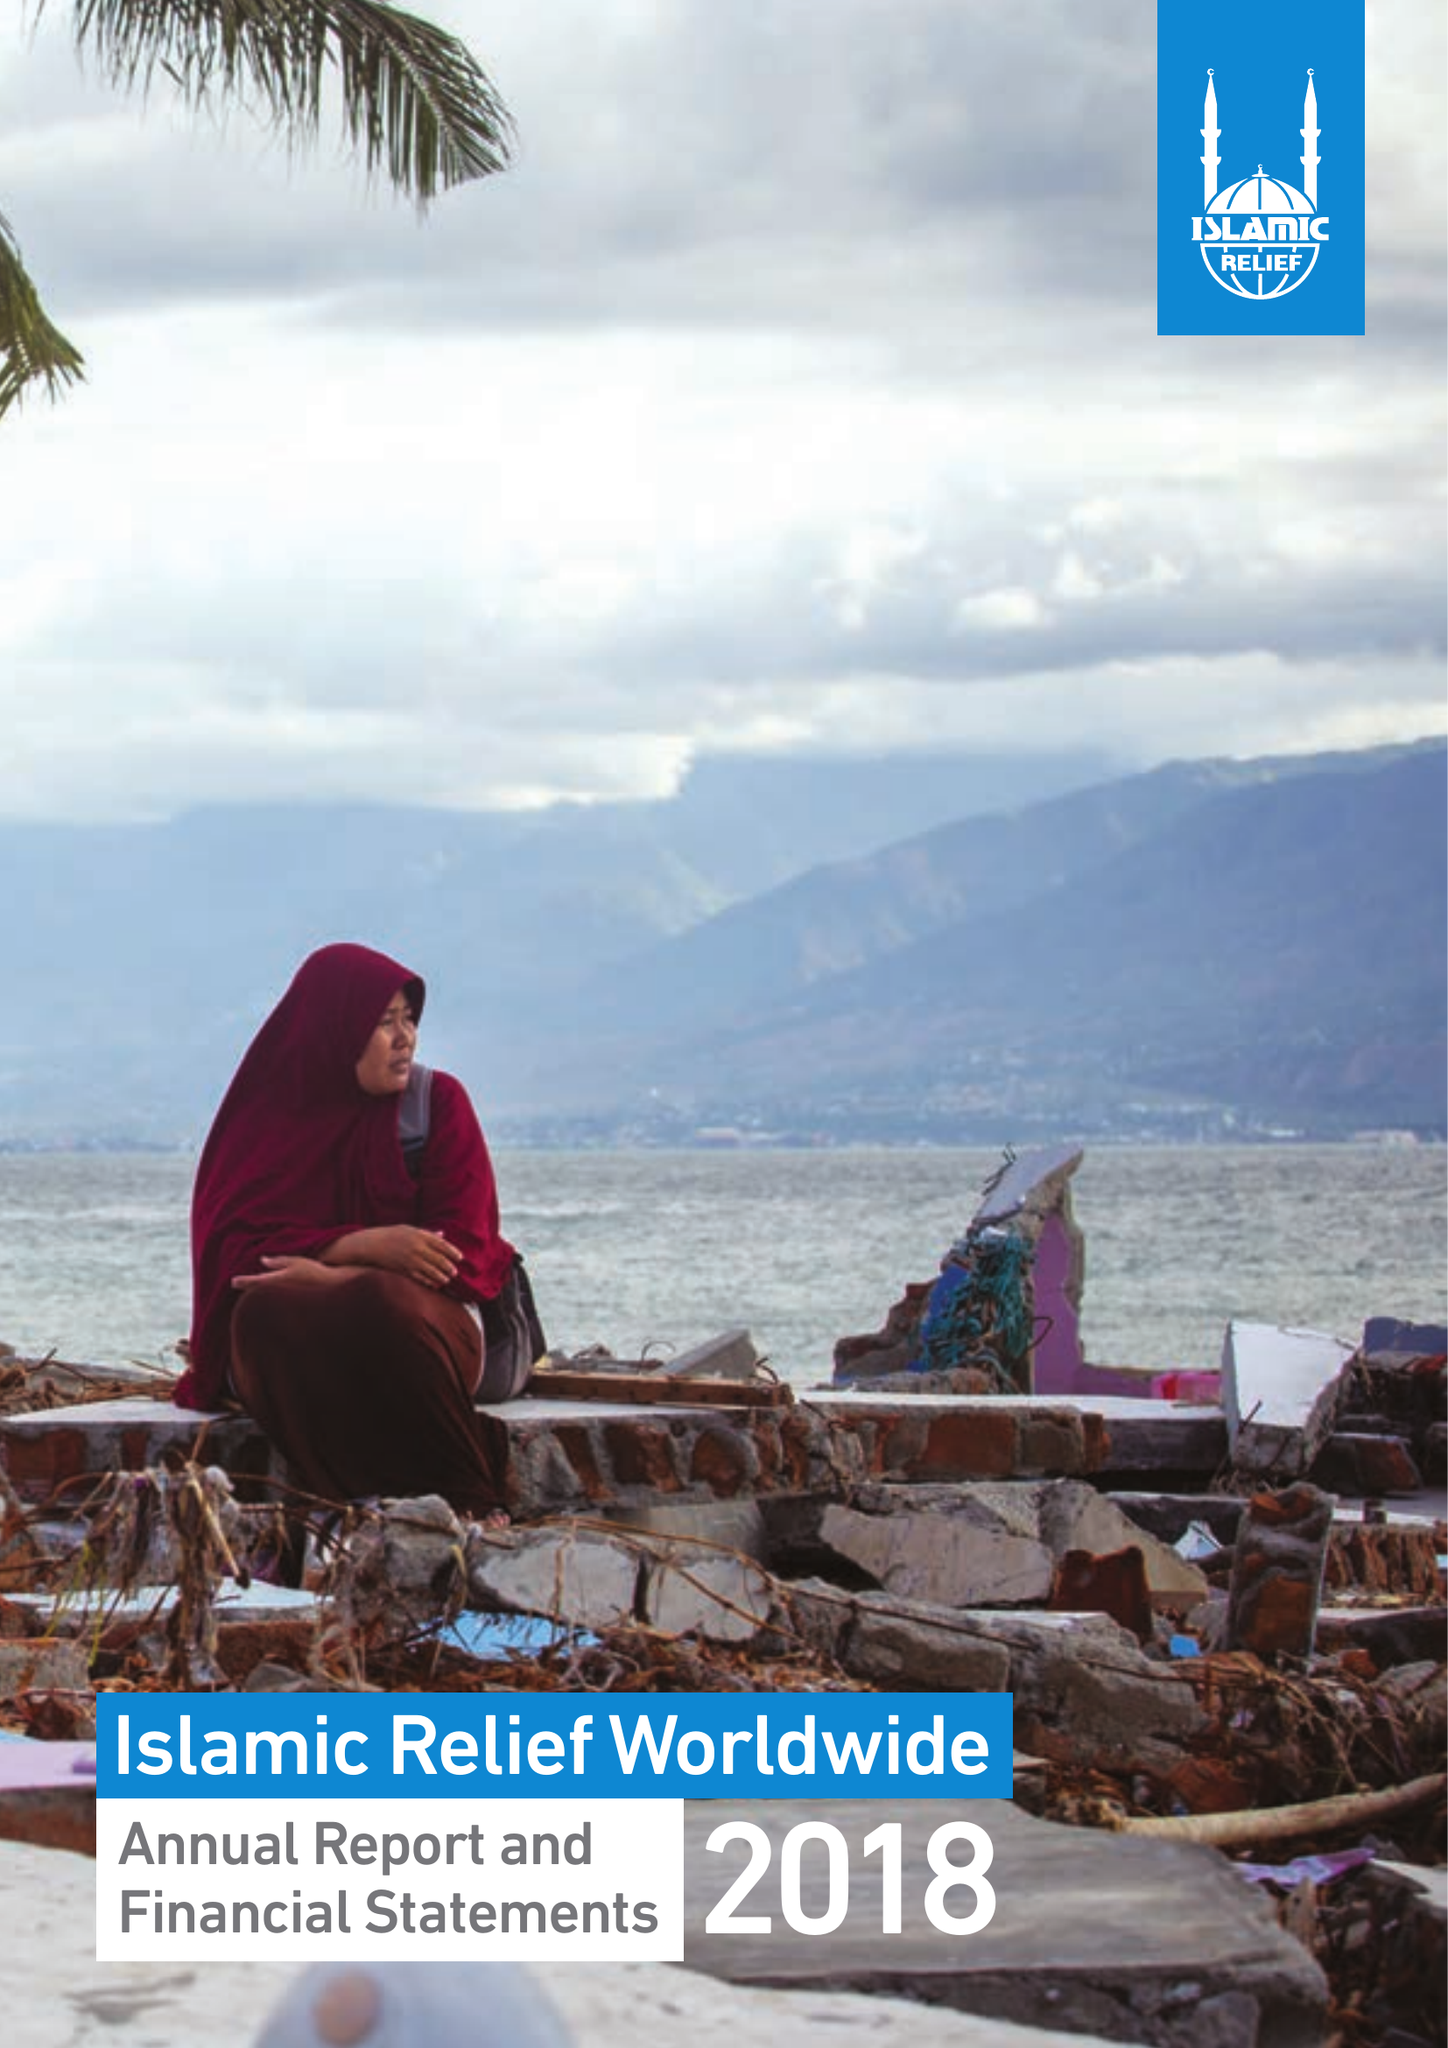What is the value for the income_annually_in_british_pounds?
Answer the question using a single word or phrase. 127934411.00 